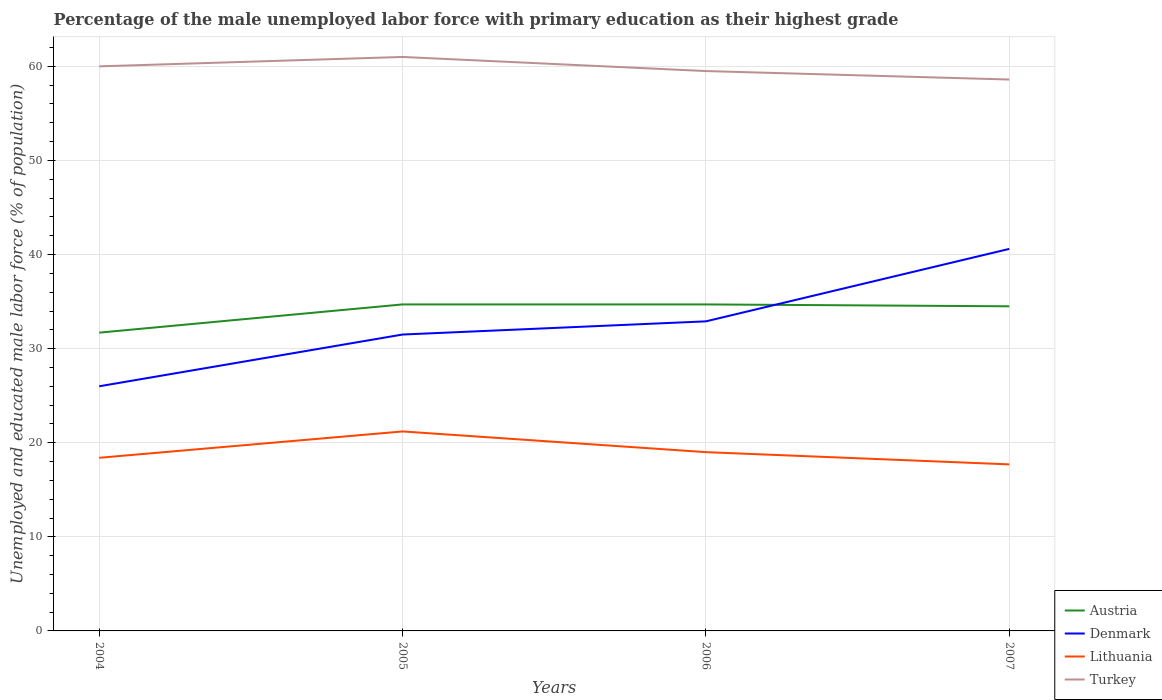How many different coloured lines are there?
Offer a terse response. 4. Across all years, what is the maximum percentage of the unemployed male labor force with primary education in Austria?
Your response must be concise. 31.7. In which year was the percentage of the unemployed male labor force with primary education in Turkey maximum?
Your answer should be compact. 2007. What is the total percentage of the unemployed male labor force with primary education in Lithuania in the graph?
Ensure brevity in your answer.  2.2. What is the difference between the highest and the second highest percentage of the unemployed male labor force with primary education in Denmark?
Offer a very short reply. 14.6. What is the difference between the highest and the lowest percentage of the unemployed male labor force with primary education in Austria?
Your answer should be compact. 3. Is the percentage of the unemployed male labor force with primary education in Austria strictly greater than the percentage of the unemployed male labor force with primary education in Turkey over the years?
Keep it short and to the point. Yes. What is the difference between two consecutive major ticks on the Y-axis?
Provide a succinct answer. 10. Are the values on the major ticks of Y-axis written in scientific E-notation?
Your response must be concise. No. Does the graph contain any zero values?
Make the answer very short. No. Does the graph contain grids?
Make the answer very short. Yes. Where does the legend appear in the graph?
Your response must be concise. Bottom right. How are the legend labels stacked?
Ensure brevity in your answer.  Vertical. What is the title of the graph?
Make the answer very short. Percentage of the male unemployed labor force with primary education as their highest grade. What is the label or title of the Y-axis?
Offer a terse response. Unemployed and educated male labor force (% of population). What is the Unemployed and educated male labor force (% of population) in Austria in 2004?
Provide a short and direct response. 31.7. What is the Unemployed and educated male labor force (% of population) of Denmark in 2004?
Make the answer very short. 26. What is the Unemployed and educated male labor force (% of population) of Lithuania in 2004?
Your answer should be compact. 18.4. What is the Unemployed and educated male labor force (% of population) in Austria in 2005?
Offer a very short reply. 34.7. What is the Unemployed and educated male labor force (% of population) of Denmark in 2005?
Your answer should be compact. 31.5. What is the Unemployed and educated male labor force (% of population) of Lithuania in 2005?
Make the answer very short. 21.2. What is the Unemployed and educated male labor force (% of population) in Turkey in 2005?
Keep it short and to the point. 61. What is the Unemployed and educated male labor force (% of population) of Austria in 2006?
Your answer should be very brief. 34.7. What is the Unemployed and educated male labor force (% of population) in Denmark in 2006?
Ensure brevity in your answer.  32.9. What is the Unemployed and educated male labor force (% of population) of Turkey in 2006?
Offer a terse response. 59.5. What is the Unemployed and educated male labor force (% of population) in Austria in 2007?
Your response must be concise. 34.5. What is the Unemployed and educated male labor force (% of population) in Denmark in 2007?
Keep it short and to the point. 40.6. What is the Unemployed and educated male labor force (% of population) of Lithuania in 2007?
Offer a very short reply. 17.7. What is the Unemployed and educated male labor force (% of population) in Turkey in 2007?
Your answer should be very brief. 58.6. Across all years, what is the maximum Unemployed and educated male labor force (% of population) of Austria?
Give a very brief answer. 34.7. Across all years, what is the maximum Unemployed and educated male labor force (% of population) of Denmark?
Make the answer very short. 40.6. Across all years, what is the maximum Unemployed and educated male labor force (% of population) in Lithuania?
Your answer should be compact. 21.2. Across all years, what is the minimum Unemployed and educated male labor force (% of population) of Austria?
Keep it short and to the point. 31.7. Across all years, what is the minimum Unemployed and educated male labor force (% of population) of Denmark?
Offer a terse response. 26. Across all years, what is the minimum Unemployed and educated male labor force (% of population) of Lithuania?
Your response must be concise. 17.7. Across all years, what is the minimum Unemployed and educated male labor force (% of population) in Turkey?
Provide a succinct answer. 58.6. What is the total Unemployed and educated male labor force (% of population) in Austria in the graph?
Offer a terse response. 135.6. What is the total Unemployed and educated male labor force (% of population) of Denmark in the graph?
Give a very brief answer. 131. What is the total Unemployed and educated male labor force (% of population) of Lithuania in the graph?
Ensure brevity in your answer.  76.3. What is the total Unemployed and educated male labor force (% of population) in Turkey in the graph?
Your response must be concise. 239.1. What is the difference between the Unemployed and educated male labor force (% of population) of Austria in 2004 and that in 2005?
Offer a terse response. -3. What is the difference between the Unemployed and educated male labor force (% of population) in Denmark in 2004 and that in 2005?
Provide a succinct answer. -5.5. What is the difference between the Unemployed and educated male labor force (% of population) in Lithuania in 2004 and that in 2006?
Your response must be concise. -0.6. What is the difference between the Unemployed and educated male labor force (% of population) in Turkey in 2004 and that in 2006?
Make the answer very short. 0.5. What is the difference between the Unemployed and educated male labor force (% of population) of Austria in 2004 and that in 2007?
Offer a terse response. -2.8. What is the difference between the Unemployed and educated male labor force (% of population) in Denmark in 2004 and that in 2007?
Your response must be concise. -14.6. What is the difference between the Unemployed and educated male labor force (% of population) of Turkey in 2004 and that in 2007?
Offer a terse response. 1.4. What is the difference between the Unemployed and educated male labor force (% of population) in Denmark in 2005 and that in 2006?
Provide a short and direct response. -1.4. What is the difference between the Unemployed and educated male labor force (% of population) in Lithuania in 2005 and that in 2006?
Offer a very short reply. 2.2. What is the difference between the Unemployed and educated male labor force (% of population) in Austria in 2005 and that in 2007?
Offer a terse response. 0.2. What is the difference between the Unemployed and educated male labor force (% of population) of Denmark in 2005 and that in 2007?
Provide a succinct answer. -9.1. What is the difference between the Unemployed and educated male labor force (% of population) in Lithuania in 2005 and that in 2007?
Your answer should be very brief. 3.5. What is the difference between the Unemployed and educated male labor force (% of population) in Turkey in 2005 and that in 2007?
Keep it short and to the point. 2.4. What is the difference between the Unemployed and educated male labor force (% of population) in Austria in 2006 and that in 2007?
Make the answer very short. 0.2. What is the difference between the Unemployed and educated male labor force (% of population) of Denmark in 2006 and that in 2007?
Provide a succinct answer. -7.7. What is the difference between the Unemployed and educated male labor force (% of population) of Austria in 2004 and the Unemployed and educated male labor force (% of population) of Lithuania in 2005?
Offer a very short reply. 10.5. What is the difference between the Unemployed and educated male labor force (% of population) in Austria in 2004 and the Unemployed and educated male labor force (% of population) in Turkey in 2005?
Provide a short and direct response. -29.3. What is the difference between the Unemployed and educated male labor force (% of population) in Denmark in 2004 and the Unemployed and educated male labor force (% of population) in Turkey in 2005?
Keep it short and to the point. -35. What is the difference between the Unemployed and educated male labor force (% of population) of Lithuania in 2004 and the Unemployed and educated male labor force (% of population) of Turkey in 2005?
Ensure brevity in your answer.  -42.6. What is the difference between the Unemployed and educated male labor force (% of population) of Austria in 2004 and the Unemployed and educated male labor force (% of population) of Lithuania in 2006?
Ensure brevity in your answer.  12.7. What is the difference between the Unemployed and educated male labor force (% of population) of Austria in 2004 and the Unemployed and educated male labor force (% of population) of Turkey in 2006?
Your answer should be very brief. -27.8. What is the difference between the Unemployed and educated male labor force (% of population) of Denmark in 2004 and the Unemployed and educated male labor force (% of population) of Lithuania in 2006?
Your response must be concise. 7. What is the difference between the Unemployed and educated male labor force (% of population) in Denmark in 2004 and the Unemployed and educated male labor force (% of population) in Turkey in 2006?
Your answer should be compact. -33.5. What is the difference between the Unemployed and educated male labor force (% of population) in Lithuania in 2004 and the Unemployed and educated male labor force (% of population) in Turkey in 2006?
Keep it short and to the point. -41.1. What is the difference between the Unemployed and educated male labor force (% of population) of Austria in 2004 and the Unemployed and educated male labor force (% of population) of Denmark in 2007?
Provide a succinct answer. -8.9. What is the difference between the Unemployed and educated male labor force (% of population) of Austria in 2004 and the Unemployed and educated male labor force (% of population) of Lithuania in 2007?
Give a very brief answer. 14. What is the difference between the Unemployed and educated male labor force (% of population) in Austria in 2004 and the Unemployed and educated male labor force (% of population) in Turkey in 2007?
Keep it short and to the point. -26.9. What is the difference between the Unemployed and educated male labor force (% of population) in Denmark in 2004 and the Unemployed and educated male labor force (% of population) in Turkey in 2007?
Provide a succinct answer. -32.6. What is the difference between the Unemployed and educated male labor force (% of population) of Lithuania in 2004 and the Unemployed and educated male labor force (% of population) of Turkey in 2007?
Keep it short and to the point. -40.2. What is the difference between the Unemployed and educated male labor force (% of population) of Austria in 2005 and the Unemployed and educated male labor force (% of population) of Lithuania in 2006?
Give a very brief answer. 15.7. What is the difference between the Unemployed and educated male labor force (% of population) in Austria in 2005 and the Unemployed and educated male labor force (% of population) in Turkey in 2006?
Offer a terse response. -24.8. What is the difference between the Unemployed and educated male labor force (% of population) of Lithuania in 2005 and the Unemployed and educated male labor force (% of population) of Turkey in 2006?
Make the answer very short. -38.3. What is the difference between the Unemployed and educated male labor force (% of population) in Austria in 2005 and the Unemployed and educated male labor force (% of population) in Lithuania in 2007?
Make the answer very short. 17. What is the difference between the Unemployed and educated male labor force (% of population) of Austria in 2005 and the Unemployed and educated male labor force (% of population) of Turkey in 2007?
Your answer should be compact. -23.9. What is the difference between the Unemployed and educated male labor force (% of population) in Denmark in 2005 and the Unemployed and educated male labor force (% of population) in Lithuania in 2007?
Your response must be concise. 13.8. What is the difference between the Unemployed and educated male labor force (% of population) of Denmark in 2005 and the Unemployed and educated male labor force (% of population) of Turkey in 2007?
Your response must be concise. -27.1. What is the difference between the Unemployed and educated male labor force (% of population) of Lithuania in 2005 and the Unemployed and educated male labor force (% of population) of Turkey in 2007?
Ensure brevity in your answer.  -37.4. What is the difference between the Unemployed and educated male labor force (% of population) in Austria in 2006 and the Unemployed and educated male labor force (% of population) in Turkey in 2007?
Give a very brief answer. -23.9. What is the difference between the Unemployed and educated male labor force (% of population) of Denmark in 2006 and the Unemployed and educated male labor force (% of population) of Lithuania in 2007?
Your response must be concise. 15.2. What is the difference between the Unemployed and educated male labor force (% of population) of Denmark in 2006 and the Unemployed and educated male labor force (% of population) of Turkey in 2007?
Offer a terse response. -25.7. What is the difference between the Unemployed and educated male labor force (% of population) of Lithuania in 2006 and the Unemployed and educated male labor force (% of population) of Turkey in 2007?
Provide a succinct answer. -39.6. What is the average Unemployed and educated male labor force (% of population) in Austria per year?
Your response must be concise. 33.9. What is the average Unemployed and educated male labor force (% of population) in Denmark per year?
Keep it short and to the point. 32.75. What is the average Unemployed and educated male labor force (% of population) in Lithuania per year?
Provide a succinct answer. 19.07. What is the average Unemployed and educated male labor force (% of population) of Turkey per year?
Provide a succinct answer. 59.77. In the year 2004, what is the difference between the Unemployed and educated male labor force (% of population) in Austria and Unemployed and educated male labor force (% of population) in Denmark?
Ensure brevity in your answer.  5.7. In the year 2004, what is the difference between the Unemployed and educated male labor force (% of population) in Austria and Unemployed and educated male labor force (% of population) in Lithuania?
Your answer should be very brief. 13.3. In the year 2004, what is the difference between the Unemployed and educated male labor force (% of population) of Austria and Unemployed and educated male labor force (% of population) of Turkey?
Make the answer very short. -28.3. In the year 2004, what is the difference between the Unemployed and educated male labor force (% of population) in Denmark and Unemployed and educated male labor force (% of population) in Lithuania?
Make the answer very short. 7.6. In the year 2004, what is the difference between the Unemployed and educated male labor force (% of population) in Denmark and Unemployed and educated male labor force (% of population) in Turkey?
Give a very brief answer. -34. In the year 2004, what is the difference between the Unemployed and educated male labor force (% of population) in Lithuania and Unemployed and educated male labor force (% of population) in Turkey?
Provide a succinct answer. -41.6. In the year 2005, what is the difference between the Unemployed and educated male labor force (% of population) of Austria and Unemployed and educated male labor force (% of population) of Lithuania?
Your response must be concise. 13.5. In the year 2005, what is the difference between the Unemployed and educated male labor force (% of population) of Austria and Unemployed and educated male labor force (% of population) of Turkey?
Make the answer very short. -26.3. In the year 2005, what is the difference between the Unemployed and educated male labor force (% of population) in Denmark and Unemployed and educated male labor force (% of population) in Turkey?
Offer a very short reply. -29.5. In the year 2005, what is the difference between the Unemployed and educated male labor force (% of population) in Lithuania and Unemployed and educated male labor force (% of population) in Turkey?
Keep it short and to the point. -39.8. In the year 2006, what is the difference between the Unemployed and educated male labor force (% of population) in Austria and Unemployed and educated male labor force (% of population) in Turkey?
Provide a short and direct response. -24.8. In the year 2006, what is the difference between the Unemployed and educated male labor force (% of population) in Denmark and Unemployed and educated male labor force (% of population) in Turkey?
Your answer should be compact. -26.6. In the year 2006, what is the difference between the Unemployed and educated male labor force (% of population) of Lithuania and Unemployed and educated male labor force (% of population) of Turkey?
Give a very brief answer. -40.5. In the year 2007, what is the difference between the Unemployed and educated male labor force (% of population) in Austria and Unemployed and educated male labor force (% of population) in Denmark?
Offer a very short reply. -6.1. In the year 2007, what is the difference between the Unemployed and educated male labor force (% of population) in Austria and Unemployed and educated male labor force (% of population) in Turkey?
Offer a very short reply. -24.1. In the year 2007, what is the difference between the Unemployed and educated male labor force (% of population) of Denmark and Unemployed and educated male labor force (% of population) of Lithuania?
Give a very brief answer. 22.9. In the year 2007, what is the difference between the Unemployed and educated male labor force (% of population) of Denmark and Unemployed and educated male labor force (% of population) of Turkey?
Make the answer very short. -18. In the year 2007, what is the difference between the Unemployed and educated male labor force (% of population) of Lithuania and Unemployed and educated male labor force (% of population) of Turkey?
Your answer should be very brief. -40.9. What is the ratio of the Unemployed and educated male labor force (% of population) in Austria in 2004 to that in 2005?
Your answer should be compact. 0.91. What is the ratio of the Unemployed and educated male labor force (% of population) of Denmark in 2004 to that in 2005?
Provide a succinct answer. 0.83. What is the ratio of the Unemployed and educated male labor force (% of population) of Lithuania in 2004 to that in 2005?
Offer a very short reply. 0.87. What is the ratio of the Unemployed and educated male labor force (% of population) of Turkey in 2004 to that in 2005?
Provide a short and direct response. 0.98. What is the ratio of the Unemployed and educated male labor force (% of population) in Austria in 2004 to that in 2006?
Offer a terse response. 0.91. What is the ratio of the Unemployed and educated male labor force (% of population) in Denmark in 2004 to that in 2006?
Make the answer very short. 0.79. What is the ratio of the Unemployed and educated male labor force (% of population) of Lithuania in 2004 to that in 2006?
Provide a succinct answer. 0.97. What is the ratio of the Unemployed and educated male labor force (% of population) in Turkey in 2004 to that in 2006?
Make the answer very short. 1.01. What is the ratio of the Unemployed and educated male labor force (% of population) in Austria in 2004 to that in 2007?
Provide a succinct answer. 0.92. What is the ratio of the Unemployed and educated male labor force (% of population) in Denmark in 2004 to that in 2007?
Your answer should be compact. 0.64. What is the ratio of the Unemployed and educated male labor force (% of population) in Lithuania in 2004 to that in 2007?
Your answer should be compact. 1.04. What is the ratio of the Unemployed and educated male labor force (% of population) in Turkey in 2004 to that in 2007?
Give a very brief answer. 1.02. What is the ratio of the Unemployed and educated male labor force (% of population) in Denmark in 2005 to that in 2006?
Keep it short and to the point. 0.96. What is the ratio of the Unemployed and educated male labor force (% of population) of Lithuania in 2005 to that in 2006?
Your response must be concise. 1.12. What is the ratio of the Unemployed and educated male labor force (% of population) of Turkey in 2005 to that in 2006?
Give a very brief answer. 1.03. What is the ratio of the Unemployed and educated male labor force (% of population) of Denmark in 2005 to that in 2007?
Your answer should be very brief. 0.78. What is the ratio of the Unemployed and educated male labor force (% of population) in Lithuania in 2005 to that in 2007?
Ensure brevity in your answer.  1.2. What is the ratio of the Unemployed and educated male labor force (% of population) in Turkey in 2005 to that in 2007?
Make the answer very short. 1.04. What is the ratio of the Unemployed and educated male labor force (% of population) of Denmark in 2006 to that in 2007?
Your answer should be very brief. 0.81. What is the ratio of the Unemployed and educated male labor force (% of population) of Lithuania in 2006 to that in 2007?
Your answer should be very brief. 1.07. What is the ratio of the Unemployed and educated male labor force (% of population) in Turkey in 2006 to that in 2007?
Ensure brevity in your answer.  1.02. What is the difference between the highest and the second highest Unemployed and educated male labor force (% of population) in Denmark?
Provide a short and direct response. 7.7. What is the difference between the highest and the lowest Unemployed and educated male labor force (% of population) in Austria?
Give a very brief answer. 3. What is the difference between the highest and the lowest Unemployed and educated male labor force (% of population) of Turkey?
Offer a very short reply. 2.4. 